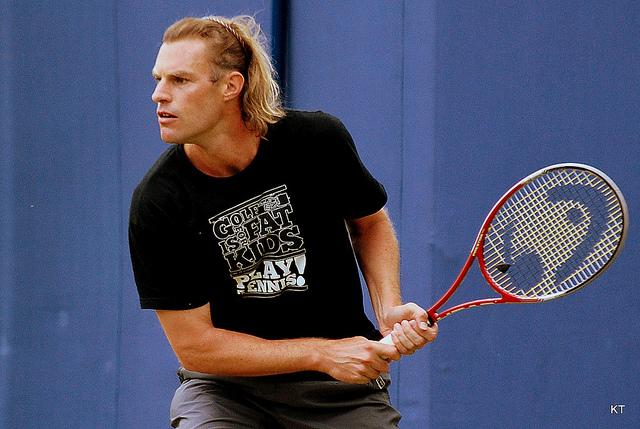Please transcribe the text information in this image. GOLF FAT IS KIDS ENNIS KT FOR PLAY 